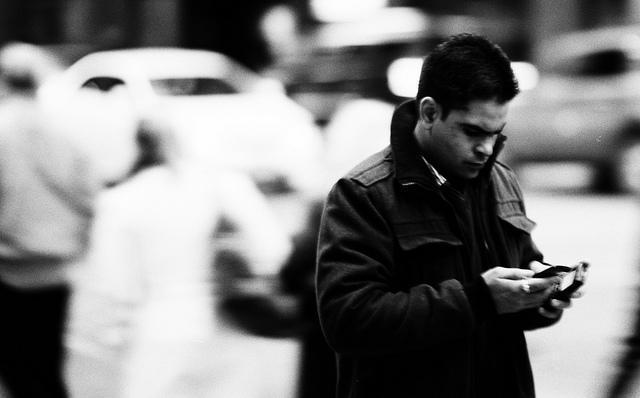How many cars can be seen?
Give a very brief answer. 2. How many people are there?
Give a very brief answer. 2. 